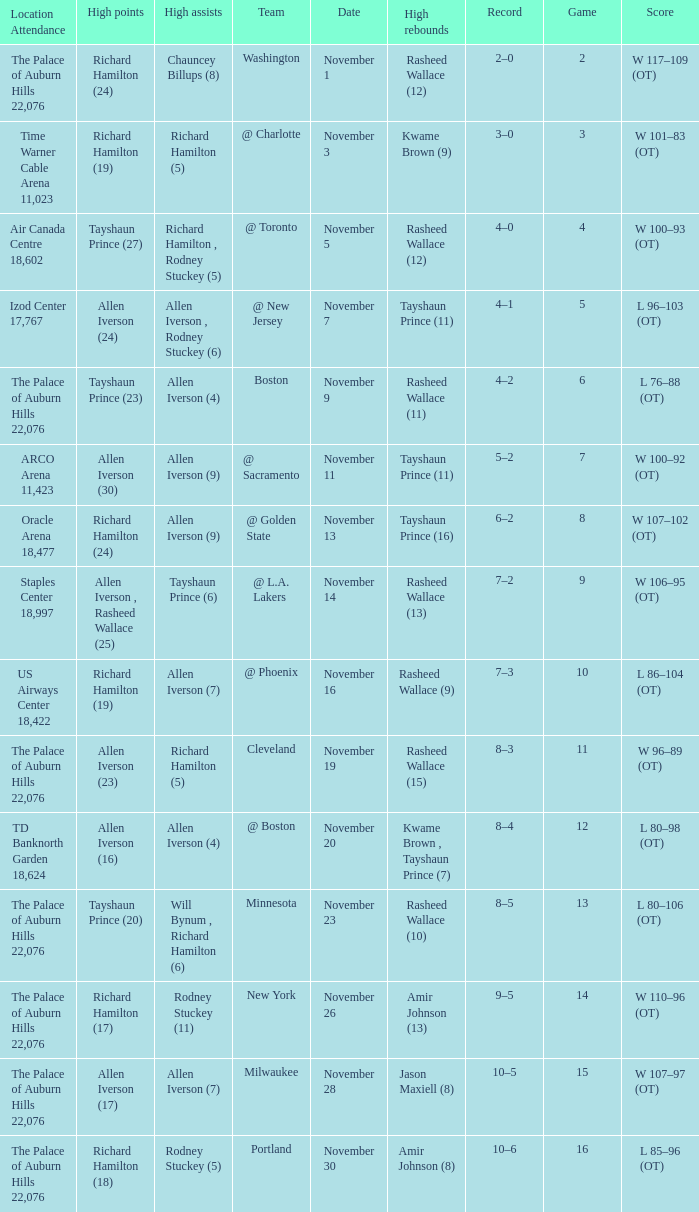What is High Points, when Game is "5"? Allen Iverson (24). 